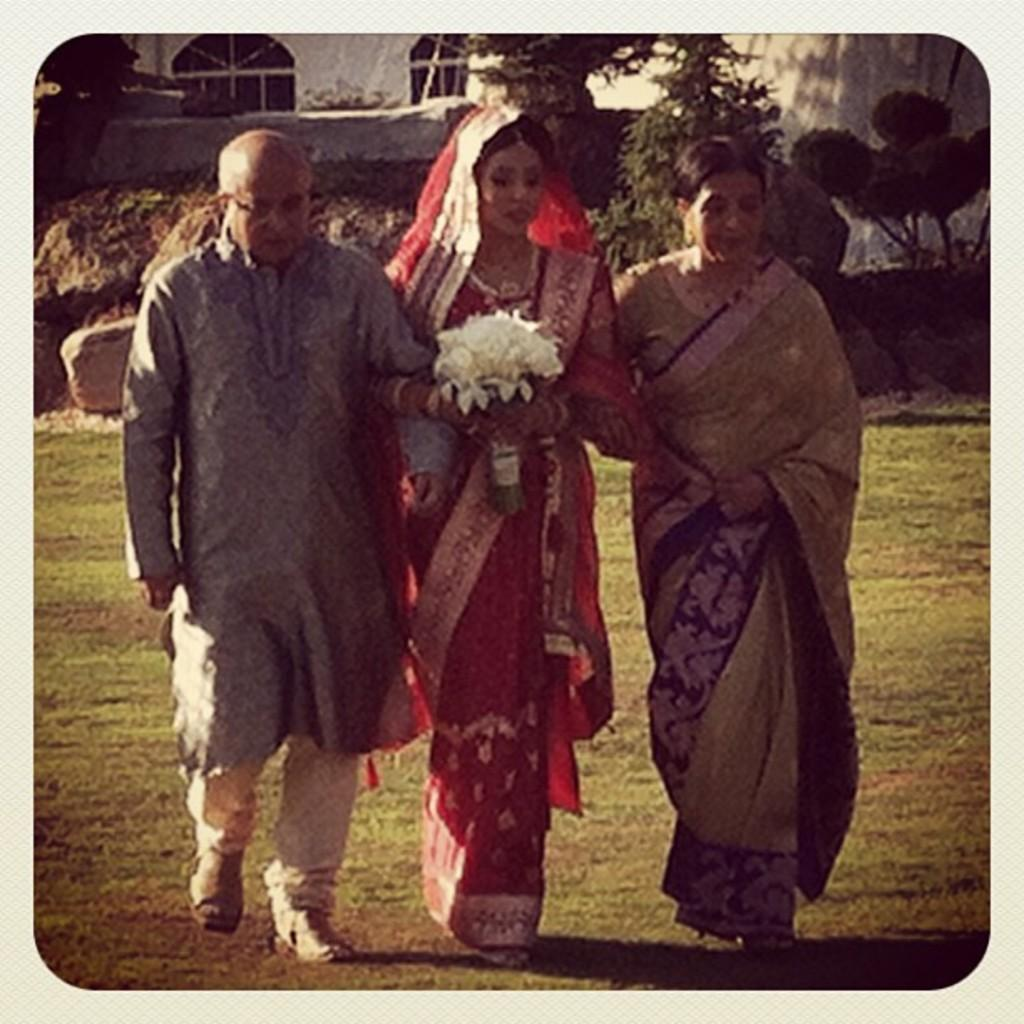How many people are in the image? There are two women and a man in the image, making a total of three individuals. What are the people in the image doing? The three individuals are standing on the ground and holding each other. What type of surface are they standing on? They are standing on the ground, which is covered with grass. What other natural elements can be seen in the image? There are plants and stones visible in the image. What type of structure is present in the background? There is a building with windows in the image. What type of kite is being flown by the man in the image? There is no kite present in the image; the man is holding two women. How many trains can be seen passing by in the image? There are no trains visible in the image. 